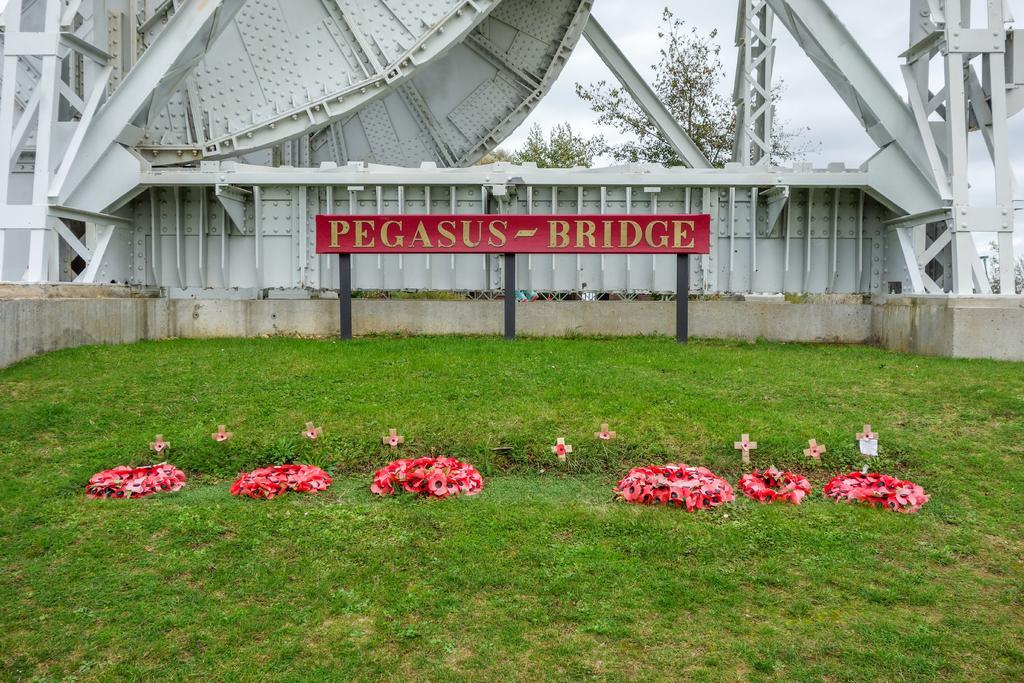Describe this image in one or two sentences. This picture is clicked outside. In the center we can see the group of garlands placed on the green grass. In the center there is a red color board on which the text is printed. In the background we can see the metal rods and metal objects and there is a sky and some trees. 